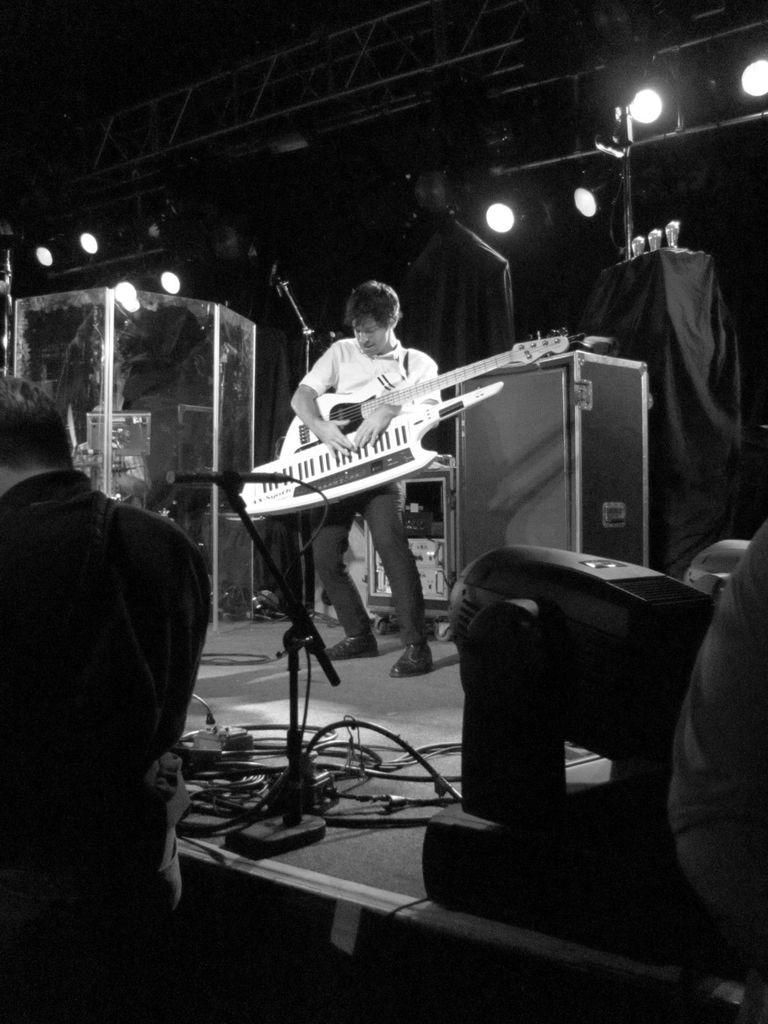What is the color scheme of the image? The image is black and white. Who is present in the image? There is a man in the image. What is the man doing in the image? The man is playing a guitar. What object is associated with the man's performance in the image? There is a microphone (mike) in the image. What else can be seen in the image related to the performance? There are cables visible in the image. What can be seen in the background of the image? There are lights in the background of the image. What time does the clock in the image show? There is no clock present in the image. What type of whip is being used by the man in the image? The man is playing a guitar, not using a whip, and there is no whip present in the image. 